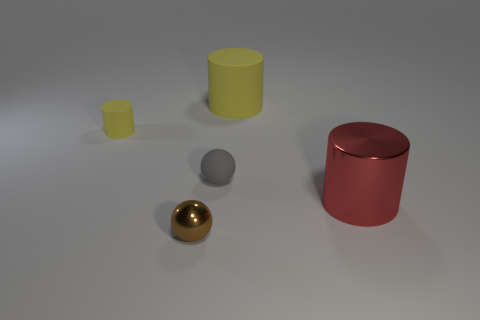Is there any object that appears capable of containing one of the others? Yes, the larger red cylinder on the right, given its open top and volume, seems capable of containing any of the smaller objects, such as the yellow cube or even the golden sphere. 